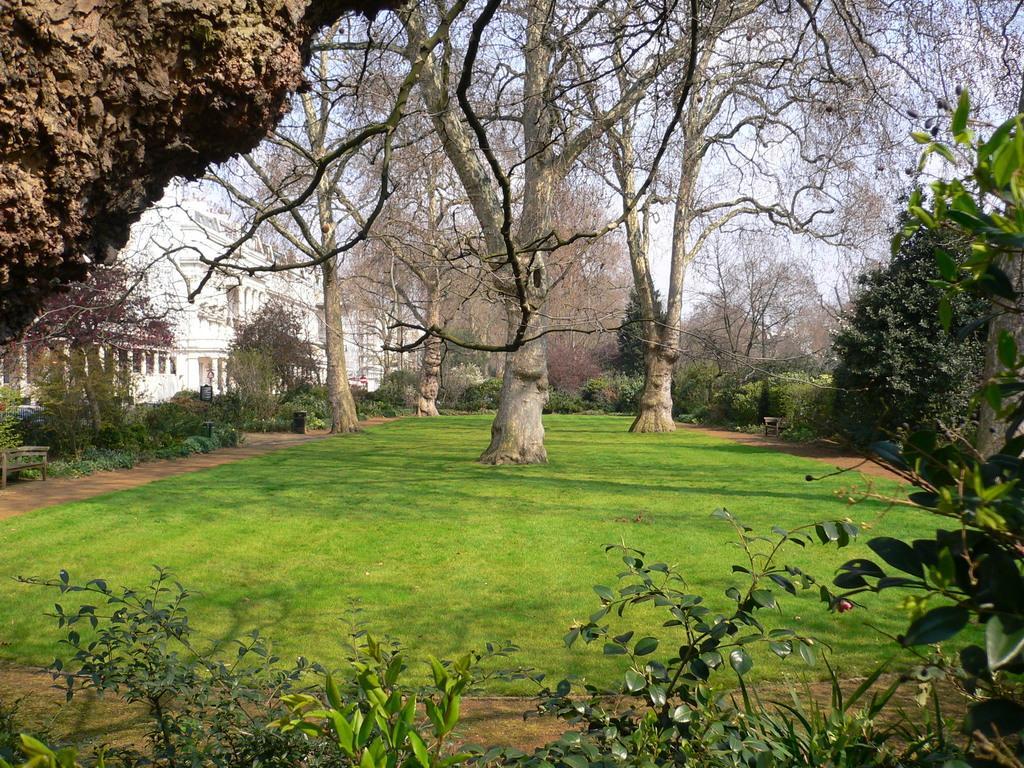Describe this image in one or two sentences. In the foreground of this image, there are few plants, grass land, trunk and few trees. In the background, there are few trees, sky and a building. 